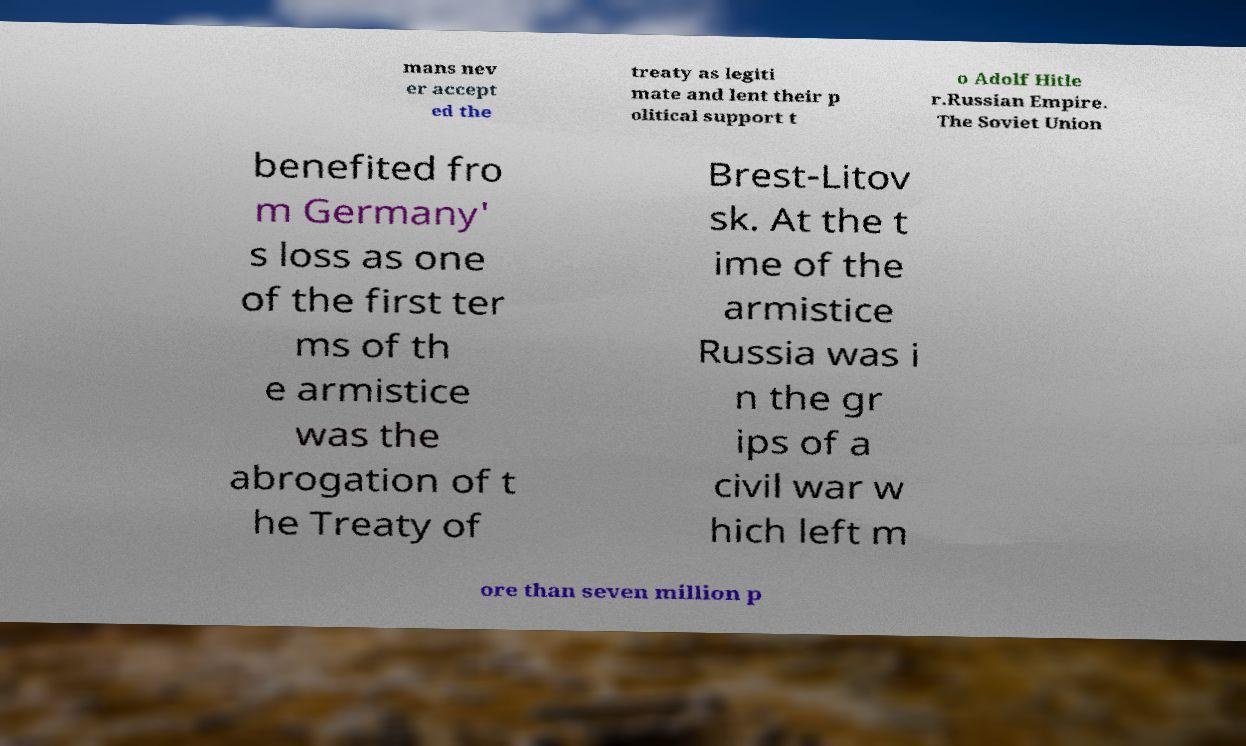Can you read and provide the text displayed in the image?This photo seems to have some interesting text. Can you extract and type it out for me? mans nev er accept ed the treaty as legiti mate and lent their p olitical support t o Adolf Hitle r.Russian Empire. The Soviet Union benefited fro m Germany' s loss as one of the first ter ms of th e armistice was the abrogation of t he Treaty of Brest-Litov sk. At the t ime of the armistice Russia was i n the gr ips of a civil war w hich left m ore than seven million p 